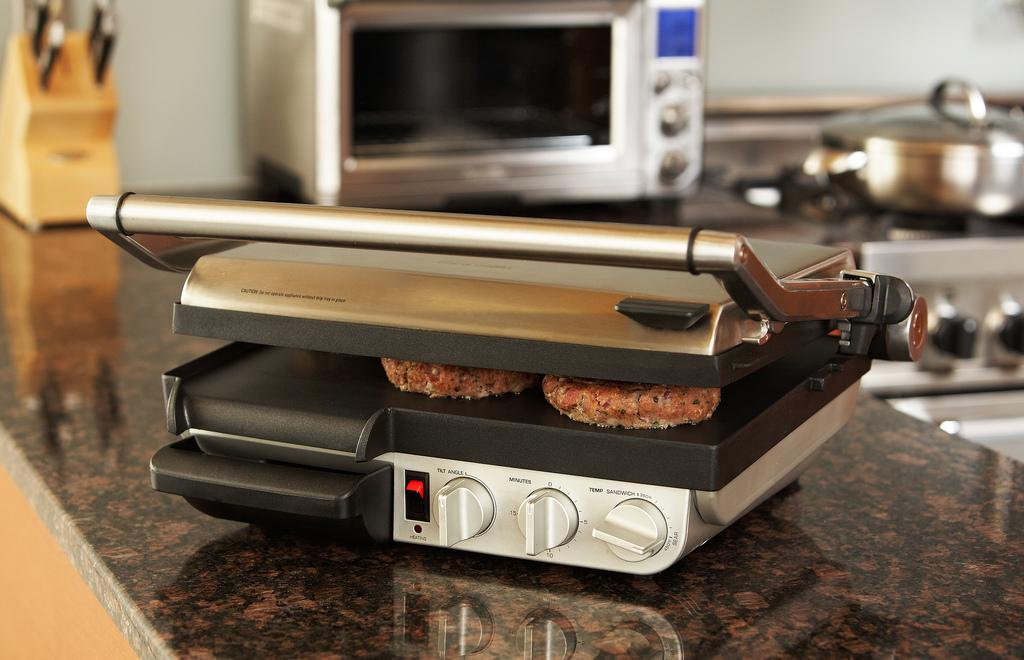<image>
Give a short and clear explanation of the subsequent image. a kitchen grill with the temperature nob set at around 450 degrees 